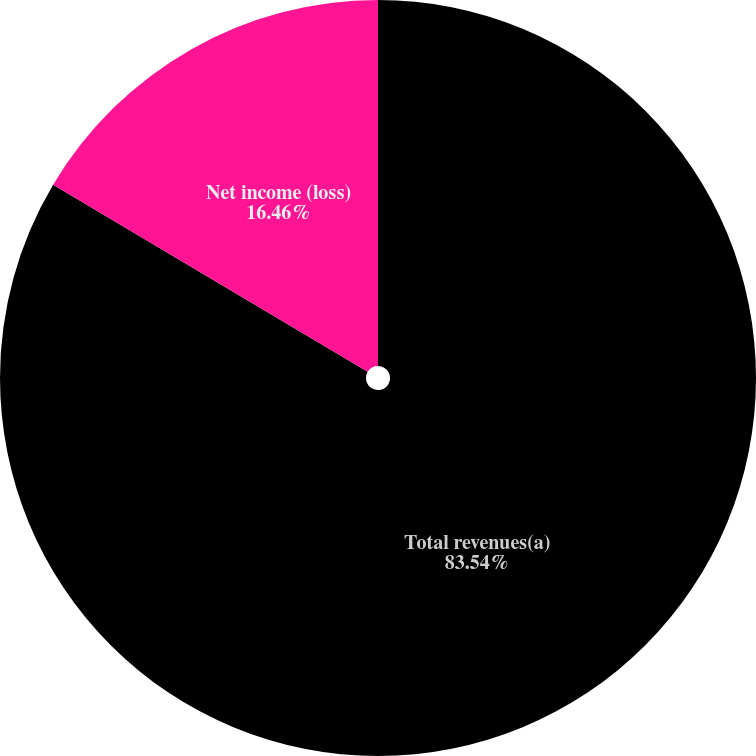Convert chart. <chart><loc_0><loc_0><loc_500><loc_500><pie_chart><fcel>Total revenues(a)<fcel>Net income (loss)<nl><fcel>83.54%<fcel>16.46%<nl></chart> 